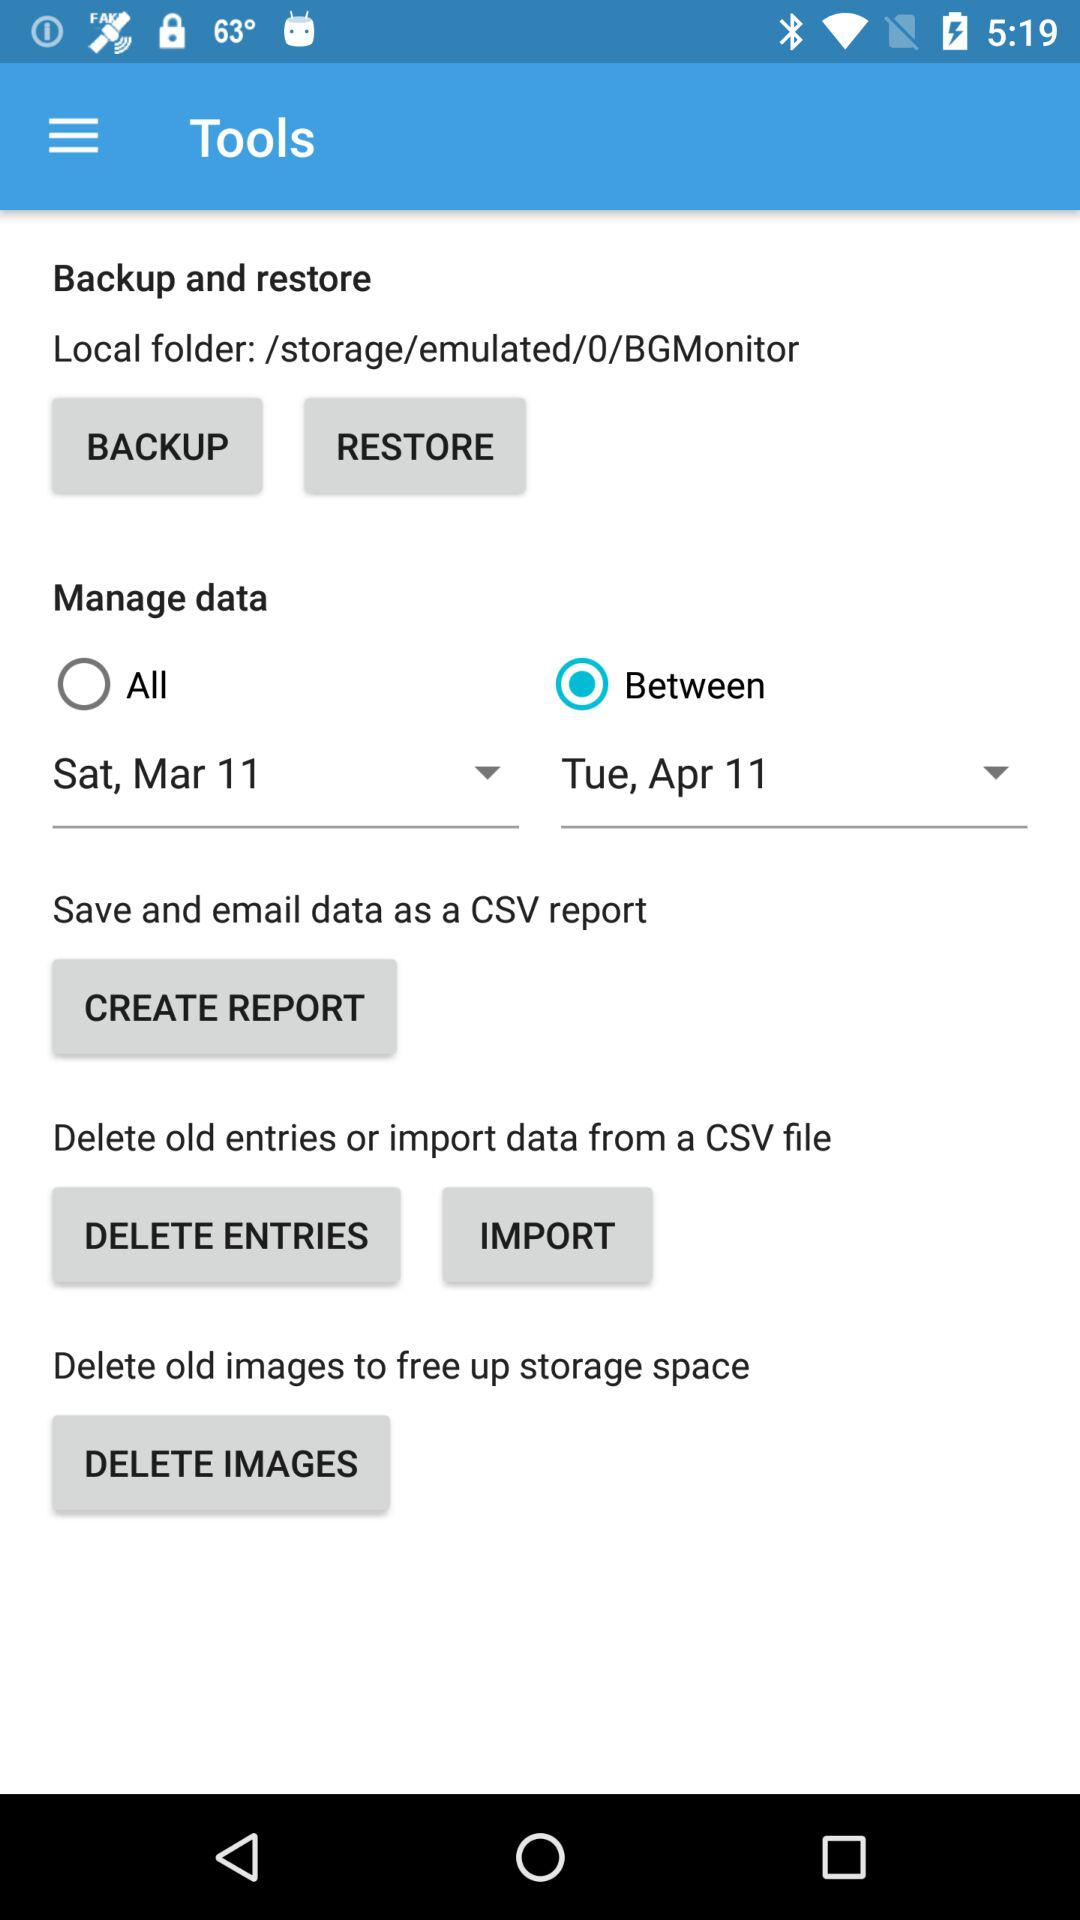What is the local folder name? The local folder name is "/storage/emulated/0/BGMonitor". 